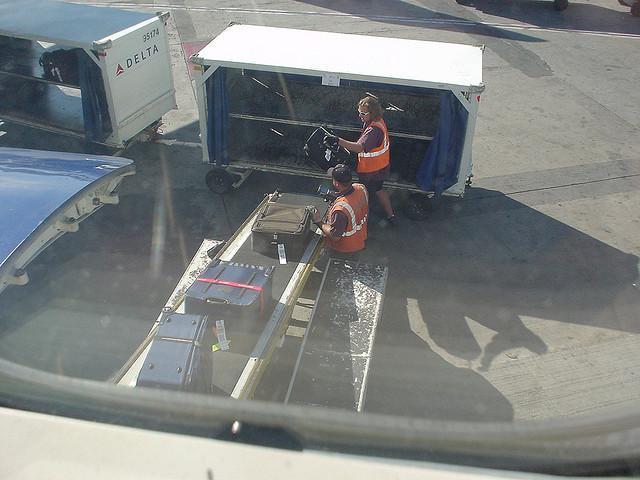How many people can be seen?
Give a very brief answer. 2. How many suitcases are visible?
Give a very brief answer. 3. 